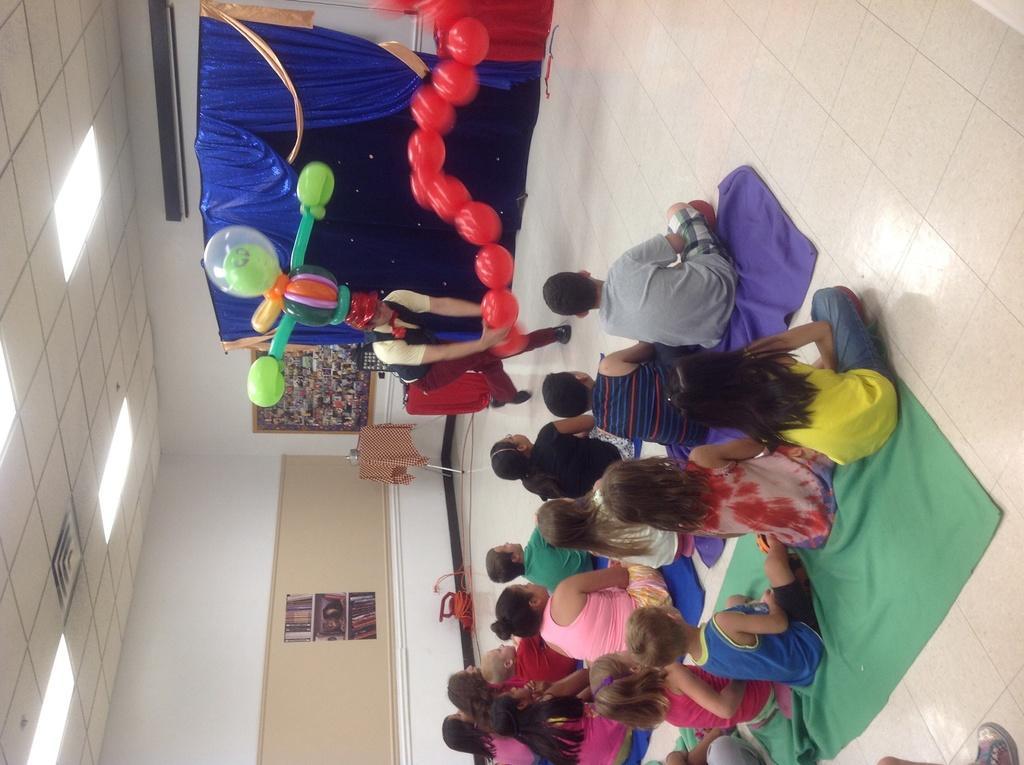Could you give a brief overview of what you see in this image? In this image there are few people sitting on the floor, there is a person in front of them holding balloons and some balloons on the head, there are lights to the roof, a curtain, a frame attached to the wall and a poster attached to the wall. 